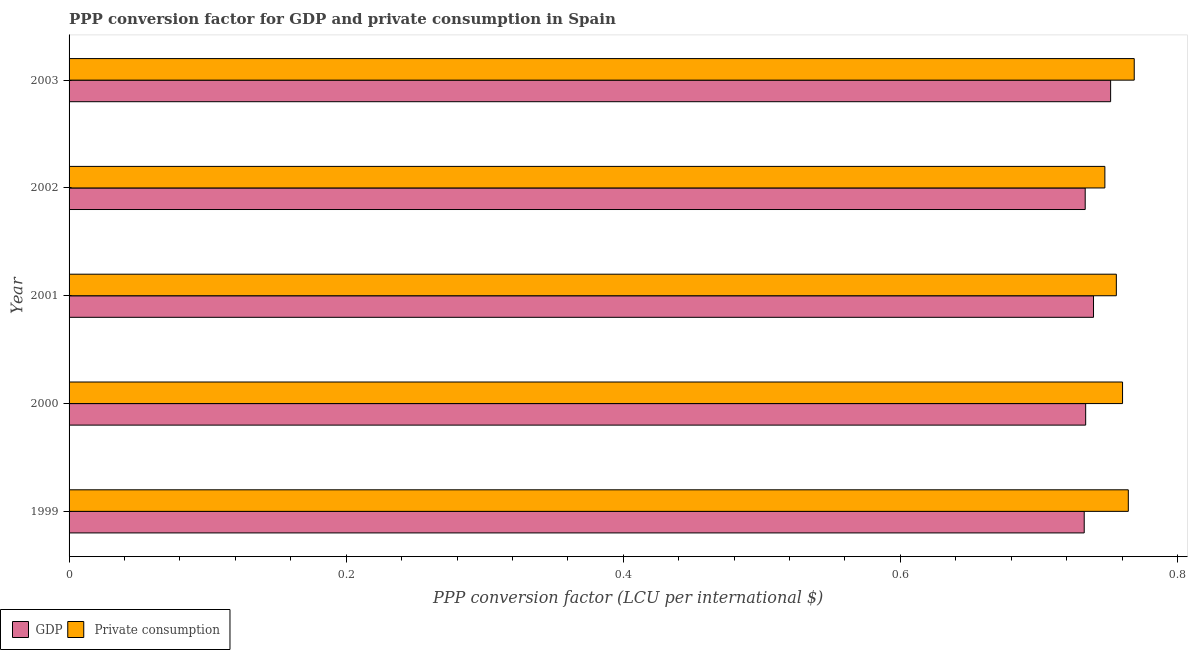Are the number of bars per tick equal to the number of legend labels?
Keep it short and to the point. Yes. Are the number of bars on each tick of the Y-axis equal?
Your response must be concise. Yes. How many bars are there on the 4th tick from the top?
Ensure brevity in your answer.  2. What is the label of the 2nd group of bars from the top?
Offer a very short reply. 2002. In how many cases, is the number of bars for a given year not equal to the number of legend labels?
Keep it short and to the point. 0. What is the ppp conversion factor for private consumption in 2000?
Provide a succinct answer. 0.76. Across all years, what is the maximum ppp conversion factor for gdp?
Offer a very short reply. 0.75. Across all years, what is the minimum ppp conversion factor for private consumption?
Keep it short and to the point. 0.75. What is the total ppp conversion factor for private consumption in the graph?
Your response must be concise. 3.8. What is the difference between the ppp conversion factor for gdp in 1999 and that in 2003?
Provide a short and direct response. -0.02. What is the difference between the ppp conversion factor for private consumption in 1999 and the ppp conversion factor for gdp in 2001?
Make the answer very short. 0.03. What is the average ppp conversion factor for private consumption per year?
Provide a short and direct response. 0.76. In the year 2000, what is the difference between the ppp conversion factor for private consumption and ppp conversion factor for gdp?
Offer a very short reply. 0.03. What is the ratio of the ppp conversion factor for gdp in 2001 to that in 2003?
Provide a short and direct response. 0.98. Is the difference between the ppp conversion factor for gdp in 2000 and 2003 greater than the difference between the ppp conversion factor for private consumption in 2000 and 2003?
Your answer should be compact. No. What is the difference between the highest and the second highest ppp conversion factor for private consumption?
Provide a short and direct response. 0. What does the 2nd bar from the top in 1999 represents?
Keep it short and to the point. GDP. What does the 2nd bar from the bottom in 1999 represents?
Offer a terse response.  Private consumption. How many bars are there?
Your answer should be very brief. 10. Are all the bars in the graph horizontal?
Give a very brief answer. Yes. Are the values on the major ticks of X-axis written in scientific E-notation?
Your answer should be compact. No. Does the graph contain any zero values?
Ensure brevity in your answer.  No. How many legend labels are there?
Your answer should be compact. 2. How are the legend labels stacked?
Provide a succinct answer. Horizontal. What is the title of the graph?
Provide a short and direct response. PPP conversion factor for GDP and private consumption in Spain. What is the label or title of the X-axis?
Provide a succinct answer. PPP conversion factor (LCU per international $). What is the label or title of the Y-axis?
Offer a terse response. Year. What is the PPP conversion factor (LCU per international $) in GDP in 1999?
Provide a short and direct response. 0.73. What is the PPP conversion factor (LCU per international $) of  Private consumption in 1999?
Make the answer very short. 0.76. What is the PPP conversion factor (LCU per international $) of GDP in 2000?
Keep it short and to the point. 0.73. What is the PPP conversion factor (LCU per international $) of  Private consumption in 2000?
Provide a succinct answer. 0.76. What is the PPP conversion factor (LCU per international $) of GDP in 2001?
Provide a succinct answer. 0.74. What is the PPP conversion factor (LCU per international $) of  Private consumption in 2001?
Offer a terse response. 0.76. What is the PPP conversion factor (LCU per international $) in GDP in 2002?
Make the answer very short. 0.73. What is the PPP conversion factor (LCU per international $) of  Private consumption in 2002?
Your answer should be very brief. 0.75. What is the PPP conversion factor (LCU per international $) in GDP in 2003?
Provide a succinct answer. 0.75. What is the PPP conversion factor (LCU per international $) in  Private consumption in 2003?
Ensure brevity in your answer.  0.77. Across all years, what is the maximum PPP conversion factor (LCU per international $) in GDP?
Keep it short and to the point. 0.75. Across all years, what is the maximum PPP conversion factor (LCU per international $) in  Private consumption?
Offer a very short reply. 0.77. Across all years, what is the minimum PPP conversion factor (LCU per international $) in GDP?
Give a very brief answer. 0.73. Across all years, what is the minimum PPP conversion factor (LCU per international $) of  Private consumption?
Your answer should be very brief. 0.75. What is the total PPP conversion factor (LCU per international $) of GDP in the graph?
Your answer should be very brief. 3.69. What is the total PPP conversion factor (LCU per international $) of  Private consumption in the graph?
Your answer should be very brief. 3.8. What is the difference between the PPP conversion factor (LCU per international $) of GDP in 1999 and that in 2000?
Keep it short and to the point. -0. What is the difference between the PPP conversion factor (LCU per international $) in  Private consumption in 1999 and that in 2000?
Provide a succinct answer. 0. What is the difference between the PPP conversion factor (LCU per international $) of GDP in 1999 and that in 2001?
Make the answer very short. -0.01. What is the difference between the PPP conversion factor (LCU per international $) in  Private consumption in 1999 and that in 2001?
Your answer should be very brief. 0.01. What is the difference between the PPP conversion factor (LCU per international $) in GDP in 1999 and that in 2002?
Ensure brevity in your answer.  -0. What is the difference between the PPP conversion factor (LCU per international $) in  Private consumption in 1999 and that in 2002?
Your response must be concise. 0.02. What is the difference between the PPP conversion factor (LCU per international $) of GDP in 1999 and that in 2003?
Offer a terse response. -0.02. What is the difference between the PPP conversion factor (LCU per international $) of  Private consumption in 1999 and that in 2003?
Your response must be concise. -0. What is the difference between the PPP conversion factor (LCU per international $) of GDP in 2000 and that in 2001?
Offer a terse response. -0.01. What is the difference between the PPP conversion factor (LCU per international $) in  Private consumption in 2000 and that in 2001?
Provide a short and direct response. 0. What is the difference between the PPP conversion factor (LCU per international $) in  Private consumption in 2000 and that in 2002?
Your answer should be very brief. 0.01. What is the difference between the PPP conversion factor (LCU per international $) of GDP in 2000 and that in 2003?
Your response must be concise. -0.02. What is the difference between the PPP conversion factor (LCU per international $) in  Private consumption in 2000 and that in 2003?
Keep it short and to the point. -0.01. What is the difference between the PPP conversion factor (LCU per international $) of GDP in 2001 and that in 2002?
Offer a terse response. 0.01. What is the difference between the PPP conversion factor (LCU per international $) in  Private consumption in 2001 and that in 2002?
Provide a succinct answer. 0.01. What is the difference between the PPP conversion factor (LCU per international $) in GDP in 2001 and that in 2003?
Keep it short and to the point. -0.01. What is the difference between the PPP conversion factor (LCU per international $) of  Private consumption in 2001 and that in 2003?
Make the answer very short. -0.01. What is the difference between the PPP conversion factor (LCU per international $) in GDP in 2002 and that in 2003?
Offer a terse response. -0.02. What is the difference between the PPP conversion factor (LCU per international $) of  Private consumption in 2002 and that in 2003?
Give a very brief answer. -0.02. What is the difference between the PPP conversion factor (LCU per international $) in GDP in 1999 and the PPP conversion factor (LCU per international $) in  Private consumption in 2000?
Ensure brevity in your answer.  -0.03. What is the difference between the PPP conversion factor (LCU per international $) in GDP in 1999 and the PPP conversion factor (LCU per international $) in  Private consumption in 2001?
Give a very brief answer. -0.02. What is the difference between the PPP conversion factor (LCU per international $) in GDP in 1999 and the PPP conversion factor (LCU per international $) in  Private consumption in 2002?
Make the answer very short. -0.01. What is the difference between the PPP conversion factor (LCU per international $) in GDP in 1999 and the PPP conversion factor (LCU per international $) in  Private consumption in 2003?
Your response must be concise. -0.04. What is the difference between the PPP conversion factor (LCU per international $) of GDP in 2000 and the PPP conversion factor (LCU per international $) of  Private consumption in 2001?
Offer a terse response. -0.02. What is the difference between the PPP conversion factor (LCU per international $) of GDP in 2000 and the PPP conversion factor (LCU per international $) of  Private consumption in 2002?
Your response must be concise. -0.01. What is the difference between the PPP conversion factor (LCU per international $) of GDP in 2000 and the PPP conversion factor (LCU per international $) of  Private consumption in 2003?
Make the answer very short. -0.04. What is the difference between the PPP conversion factor (LCU per international $) in GDP in 2001 and the PPP conversion factor (LCU per international $) in  Private consumption in 2002?
Make the answer very short. -0.01. What is the difference between the PPP conversion factor (LCU per international $) in GDP in 2001 and the PPP conversion factor (LCU per international $) in  Private consumption in 2003?
Keep it short and to the point. -0.03. What is the difference between the PPP conversion factor (LCU per international $) of GDP in 2002 and the PPP conversion factor (LCU per international $) of  Private consumption in 2003?
Give a very brief answer. -0.04. What is the average PPP conversion factor (LCU per international $) in GDP per year?
Your response must be concise. 0.74. What is the average PPP conversion factor (LCU per international $) in  Private consumption per year?
Provide a succinct answer. 0.76. In the year 1999, what is the difference between the PPP conversion factor (LCU per international $) of GDP and PPP conversion factor (LCU per international $) of  Private consumption?
Keep it short and to the point. -0.03. In the year 2000, what is the difference between the PPP conversion factor (LCU per international $) in GDP and PPP conversion factor (LCU per international $) in  Private consumption?
Your answer should be compact. -0.03. In the year 2001, what is the difference between the PPP conversion factor (LCU per international $) of GDP and PPP conversion factor (LCU per international $) of  Private consumption?
Give a very brief answer. -0.02. In the year 2002, what is the difference between the PPP conversion factor (LCU per international $) in GDP and PPP conversion factor (LCU per international $) in  Private consumption?
Provide a succinct answer. -0.01. In the year 2003, what is the difference between the PPP conversion factor (LCU per international $) in GDP and PPP conversion factor (LCU per international $) in  Private consumption?
Your answer should be compact. -0.02. What is the ratio of the PPP conversion factor (LCU per international $) of GDP in 1999 to that in 2001?
Ensure brevity in your answer.  0.99. What is the ratio of the PPP conversion factor (LCU per international $) in  Private consumption in 1999 to that in 2001?
Keep it short and to the point. 1.01. What is the ratio of the PPP conversion factor (LCU per international $) in GDP in 1999 to that in 2002?
Your answer should be very brief. 1. What is the ratio of the PPP conversion factor (LCU per international $) of  Private consumption in 1999 to that in 2002?
Provide a succinct answer. 1.02. What is the ratio of the PPP conversion factor (LCU per international $) in GDP in 1999 to that in 2003?
Provide a short and direct response. 0.97. What is the ratio of the PPP conversion factor (LCU per international $) in  Private consumption in 1999 to that in 2003?
Offer a very short reply. 0.99. What is the ratio of the PPP conversion factor (LCU per international $) in  Private consumption in 2000 to that in 2001?
Offer a terse response. 1.01. What is the ratio of the PPP conversion factor (LCU per international $) in GDP in 2000 to that in 2002?
Make the answer very short. 1. What is the ratio of the PPP conversion factor (LCU per international $) in  Private consumption in 2000 to that in 2002?
Your answer should be very brief. 1.02. What is the ratio of the PPP conversion factor (LCU per international $) in GDP in 2001 to that in 2002?
Give a very brief answer. 1.01. What is the ratio of the PPP conversion factor (LCU per international $) in  Private consumption in 2001 to that in 2002?
Your response must be concise. 1.01. What is the ratio of the PPP conversion factor (LCU per international $) in GDP in 2001 to that in 2003?
Offer a very short reply. 0.98. What is the ratio of the PPP conversion factor (LCU per international $) in  Private consumption in 2001 to that in 2003?
Your answer should be compact. 0.98. What is the ratio of the PPP conversion factor (LCU per international $) in GDP in 2002 to that in 2003?
Keep it short and to the point. 0.98. What is the ratio of the PPP conversion factor (LCU per international $) of  Private consumption in 2002 to that in 2003?
Provide a short and direct response. 0.97. What is the difference between the highest and the second highest PPP conversion factor (LCU per international $) in GDP?
Your response must be concise. 0.01. What is the difference between the highest and the second highest PPP conversion factor (LCU per international $) in  Private consumption?
Your answer should be compact. 0. What is the difference between the highest and the lowest PPP conversion factor (LCU per international $) in GDP?
Give a very brief answer. 0.02. What is the difference between the highest and the lowest PPP conversion factor (LCU per international $) of  Private consumption?
Provide a succinct answer. 0.02. 